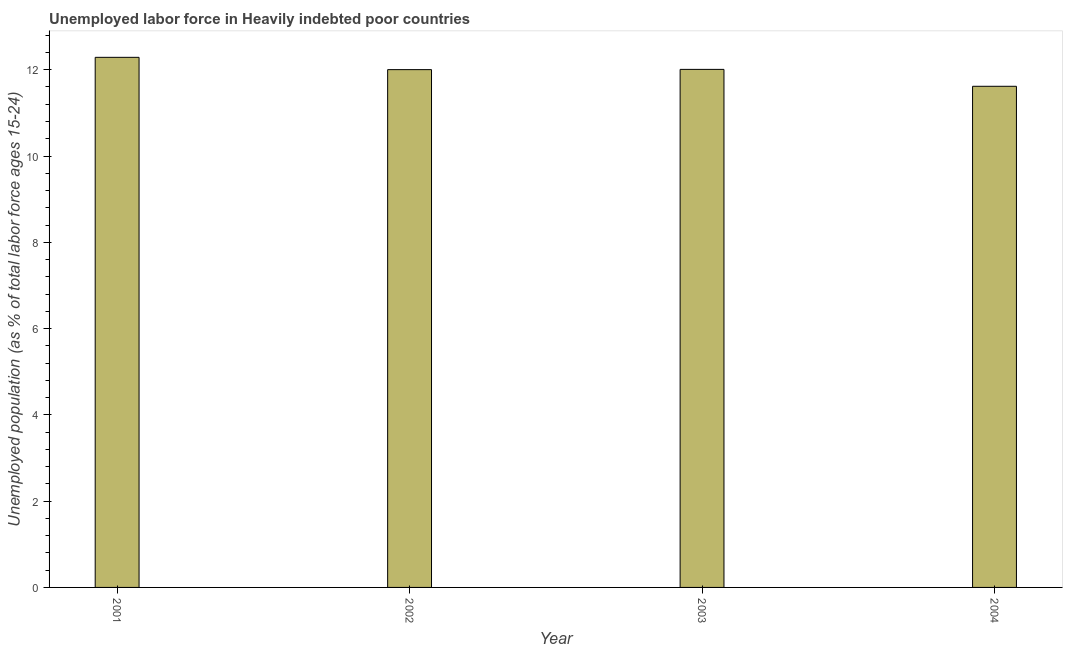Does the graph contain grids?
Your answer should be very brief. No. What is the title of the graph?
Your answer should be compact. Unemployed labor force in Heavily indebted poor countries. What is the label or title of the X-axis?
Provide a succinct answer. Year. What is the label or title of the Y-axis?
Give a very brief answer. Unemployed population (as % of total labor force ages 15-24). What is the total unemployed youth population in 2001?
Ensure brevity in your answer.  12.29. Across all years, what is the maximum total unemployed youth population?
Offer a terse response. 12.29. Across all years, what is the minimum total unemployed youth population?
Give a very brief answer. 11.62. In which year was the total unemployed youth population maximum?
Offer a very short reply. 2001. What is the sum of the total unemployed youth population?
Make the answer very short. 47.91. What is the difference between the total unemployed youth population in 2001 and 2004?
Your response must be concise. 0.67. What is the average total unemployed youth population per year?
Your response must be concise. 11.98. What is the median total unemployed youth population?
Offer a terse response. 12. In how many years, is the total unemployed youth population greater than 3.6 %?
Your answer should be compact. 4. What is the difference between the highest and the second highest total unemployed youth population?
Keep it short and to the point. 0.28. Is the sum of the total unemployed youth population in 2002 and 2003 greater than the maximum total unemployed youth population across all years?
Offer a terse response. Yes. What is the difference between the highest and the lowest total unemployed youth population?
Your response must be concise. 0.67. In how many years, is the total unemployed youth population greater than the average total unemployed youth population taken over all years?
Offer a terse response. 3. How many bars are there?
Make the answer very short. 4. How many years are there in the graph?
Your answer should be very brief. 4. What is the Unemployed population (as % of total labor force ages 15-24) of 2001?
Keep it short and to the point. 12.29. What is the Unemployed population (as % of total labor force ages 15-24) in 2002?
Keep it short and to the point. 12. What is the Unemployed population (as % of total labor force ages 15-24) of 2003?
Provide a succinct answer. 12.01. What is the Unemployed population (as % of total labor force ages 15-24) in 2004?
Keep it short and to the point. 11.62. What is the difference between the Unemployed population (as % of total labor force ages 15-24) in 2001 and 2002?
Keep it short and to the point. 0.29. What is the difference between the Unemployed population (as % of total labor force ages 15-24) in 2001 and 2003?
Your answer should be very brief. 0.28. What is the difference between the Unemployed population (as % of total labor force ages 15-24) in 2001 and 2004?
Offer a very short reply. 0.67. What is the difference between the Unemployed population (as % of total labor force ages 15-24) in 2002 and 2003?
Your answer should be very brief. -0.01. What is the difference between the Unemployed population (as % of total labor force ages 15-24) in 2002 and 2004?
Give a very brief answer. 0.39. What is the difference between the Unemployed population (as % of total labor force ages 15-24) in 2003 and 2004?
Make the answer very short. 0.39. What is the ratio of the Unemployed population (as % of total labor force ages 15-24) in 2001 to that in 2004?
Ensure brevity in your answer.  1.06. What is the ratio of the Unemployed population (as % of total labor force ages 15-24) in 2002 to that in 2004?
Your response must be concise. 1.03. What is the ratio of the Unemployed population (as % of total labor force ages 15-24) in 2003 to that in 2004?
Your answer should be very brief. 1.03. 